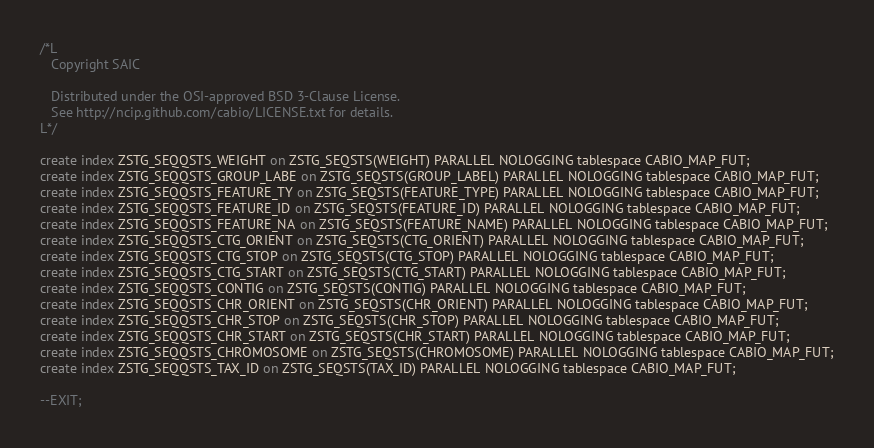<code> <loc_0><loc_0><loc_500><loc_500><_SQL_>/*L
   Copyright SAIC

   Distributed under the OSI-approved BSD 3-Clause License.
   See http://ncip.github.com/cabio/LICENSE.txt for details.
L*/

create index ZSTG_SEQQSTS_WEIGHT on ZSTG_SEQSTS(WEIGHT) PARALLEL NOLOGGING tablespace CABIO_MAP_FUT;
create index ZSTG_SEQQSTS_GROUP_LABE on ZSTG_SEQSTS(GROUP_LABEL) PARALLEL NOLOGGING tablespace CABIO_MAP_FUT;
create index ZSTG_SEQQSTS_FEATURE_TY on ZSTG_SEQSTS(FEATURE_TYPE) PARALLEL NOLOGGING tablespace CABIO_MAP_FUT;
create index ZSTG_SEQQSTS_FEATURE_ID on ZSTG_SEQSTS(FEATURE_ID) PARALLEL NOLOGGING tablespace CABIO_MAP_FUT;
create index ZSTG_SEQQSTS_FEATURE_NA on ZSTG_SEQSTS(FEATURE_NAME) PARALLEL NOLOGGING tablespace CABIO_MAP_FUT;
create index ZSTG_SEQQSTS_CTG_ORIENT on ZSTG_SEQSTS(CTG_ORIENT) PARALLEL NOLOGGING tablespace CABIO_MAP_FUT;
create index ZSTG_SEQQSTS_CTG_STOP on ZSTG_SEQSTS(CTG_STOP) PARALLEL NOLOGGING tablespace CABIO_MAP_FUT;
create index ZSTG_SEQQSTS_CTG_START on ZSTG_SEQSTS(CTG_START) PARALLEL NOLOGGING tablespace CABIO_MAP_FUT;
create index ZSTG_SEQQSTS_CONTIG on ZSTG_SEQSTS(CONTIG) PARALLEL NOLOGGING tablespace CABIO_MAP_FUT;
create index ZSTG_SEQQSTS_CHR_ORIENT on ZSTG_SEQSTS(CHR_ORIENT) PARALLEL NOLOGGING tablespace CABIO_MAP_FUT;
create index ZSTG_SEQQSTS_CHR_STOP on ZSTG_SEQSTS(CHR_STOP) PARALLEL NOLOGGING tablespace CABIO_MAP_FUT;
create index ZSTG_SEQQSTS_CHR_START on ZSTG_SEQSTS(CHR_START) PARALLEL NOLOGGING tablespace CABIO_MAP_FUT;
create index ZSTG_SEQQSTS_CHROMOSOME on ZSTG_SEQSTS(CHROMOSOME) PARALLEL NOLOGGING tablespace CABIO_MAP_FUT;
create index ZSTG_SEQQSTS_TAX_ID on ZSTG_SEQSTS(TAX_ID) PARALLEL NOLOGGING tablespace CABIO_MAP_FUT;

--EXIT;
</code> 